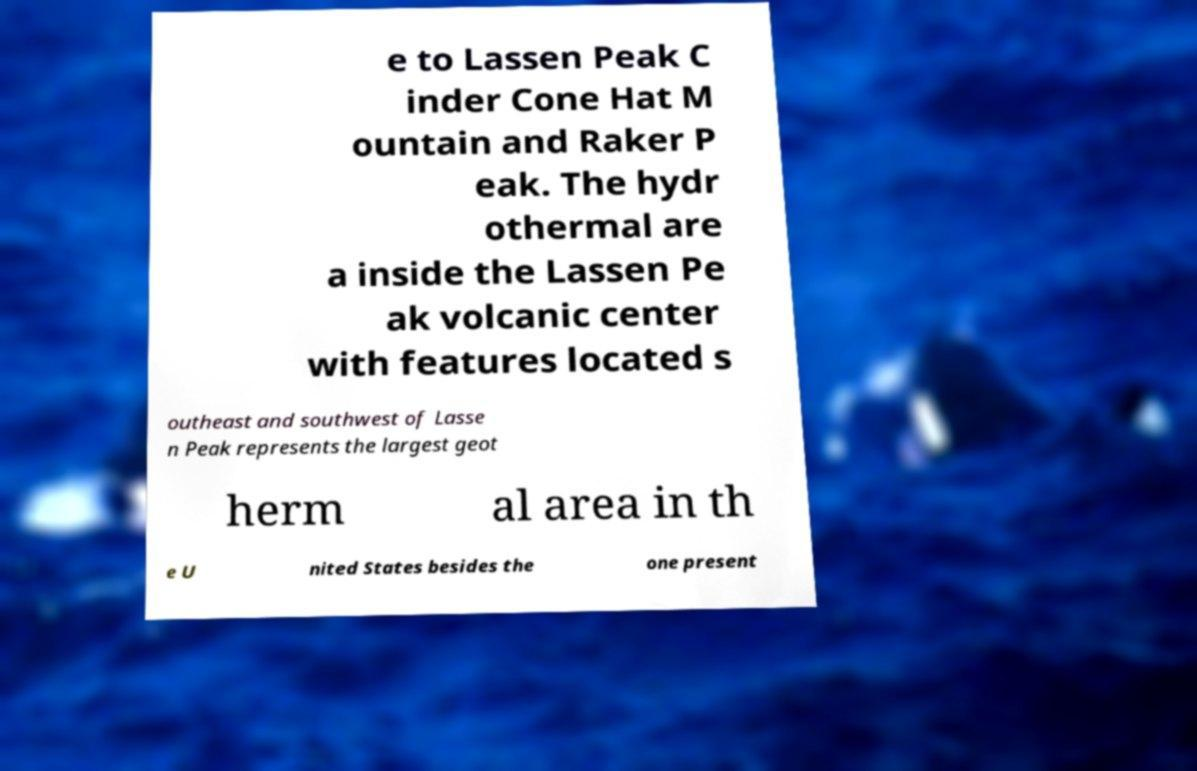Can you read and provide the text displayed in the image?This photo seems to have some interesting text. Can you extract and type it out for me? e to Lassen Peak C inder Cone Hat M ountain and Raker P eak. The hydr othermal are a inside the Lassen Pe ak volcanic center with features located s outheast and southwest of Lasse n Peak represents the largest geot herm al area in th e U nited States besides the one present 